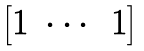Convert formula to latex. <formula><loc_0><loc_0><loc_500><loc_500>\begin{bmatrix} 1 & \cdots & 1 \end{bmatrix}</formula> 